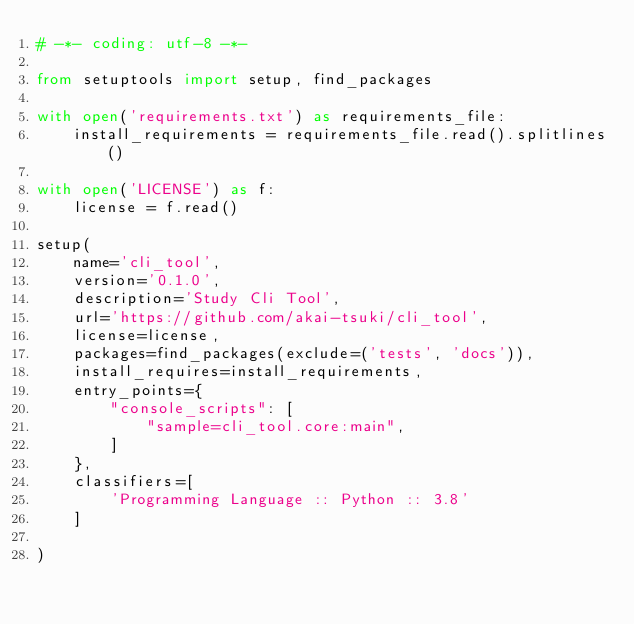<code> <loc_0><loc_0><loc_500><loc_500><_Python_># -*- coding: utf-8 -*-

from setuptools import setup, find_packages

with open('requirements.txt') as requirements_file:
    install_requirements = requirements_file.read().splitlines()

with open('LICENSE') as f:
    license = f.read()

setup(
    name='cli_tool',
    version='0.1.0',
    description='Study Cli Tool',
    url='https://github.com/akai-tsuki/cli_tool',
    license=license,
    packages=find_packages(exclude=('tests', 'docs')),
    install_requires=install_requirements,
    entry_points={
        "console_scripts": [
            "sample=cli_tool.core:main",
        ]
    },
    classifiers=[
        'Programming Language :: Python :: 3.8'
    ]

)
</code> 